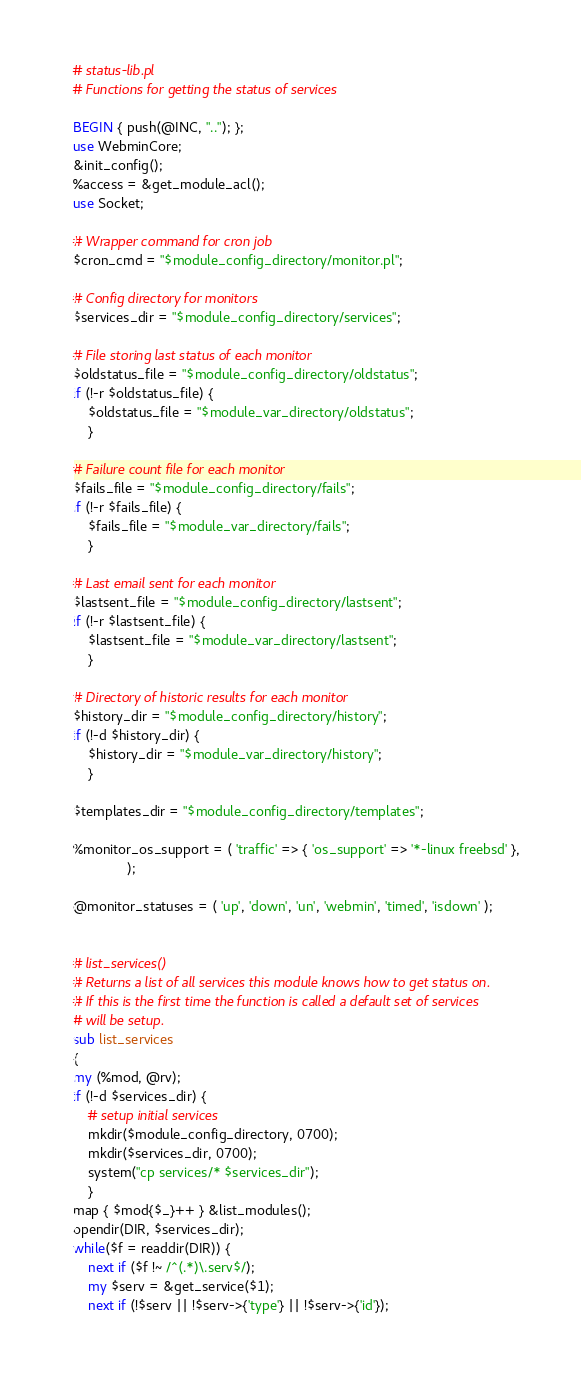Convert code to text. <code><loc_0><loc_0><loc_500><loc_500><_Perl_># status-lib.pl
# Functions for getting the status of services

BEGIN { push(@INC, ".."); };
use WebminCore;
&init_config();
%access = &get_module_acl();
use Socket;

# Wrapper command for cron job
$cron_cmd = "$module_config_directory/monitor.pl";

# Config directory for monitors
$services_dir = "$module_config_directory/services";

# File storing last status of each monitor
$oldstatus_file = "$module_config_directory/oldstatus";
if (!-r $oldstatus_file) {
	$oldstatus_file = "$module_var_directory/oldstatus";
	}

# Failure count file for each monitor
$fails_file = "$module_config_directory/fails";
if (!-r $fails_file) {
	$fails_file = "$module_var_directory/fails";
	}

# Last email sent for each monitor
$lastsent_file = "$module_config_directory/lastsent";
if (!-r $lastsent_file) {
	$lastsent_file = "$module_var_directory/lastsent";
	}

# Directory of historic results for each monitor
$history_dir = "$module_config_directory/history";
if (!-d $history_dir) {
	$history_dir = "$module_var_directory/history";
	}

$templates_dir = "$module_config_directory/templates";

%monitor_os_support = ( 'traffic' => { 'os_support' => '*-linux freebsd' },
		      );

@monitor_statuses = ( 'up', 'down', 'un', 'webmin', 'timed', 'isdown' );


# list_services()
# Returns a list of all services this module knows how to get status on.
# If this is the first time the function is called a default set of services
# will be setup.
sub list_services
{
my (%mod, @rv);
if (!-d $services_dir) {
	# setup initial services
	mkdir($module_config_directory, 0700);
	mkdir($services_dir, 0700);
	system("cp services/* $services_dir");
	}
map { $mod{$_}++ } &list_modules();
opendir(DIR, $services_dir);
while($f = readdir(DIR)) {
	next if ($f !~ /^(.*)\.serv$/);
	my $serv = &get_service($1);
	next if (!$serv || !$serv->{'type'} || !$serv->{'id'});</code> 